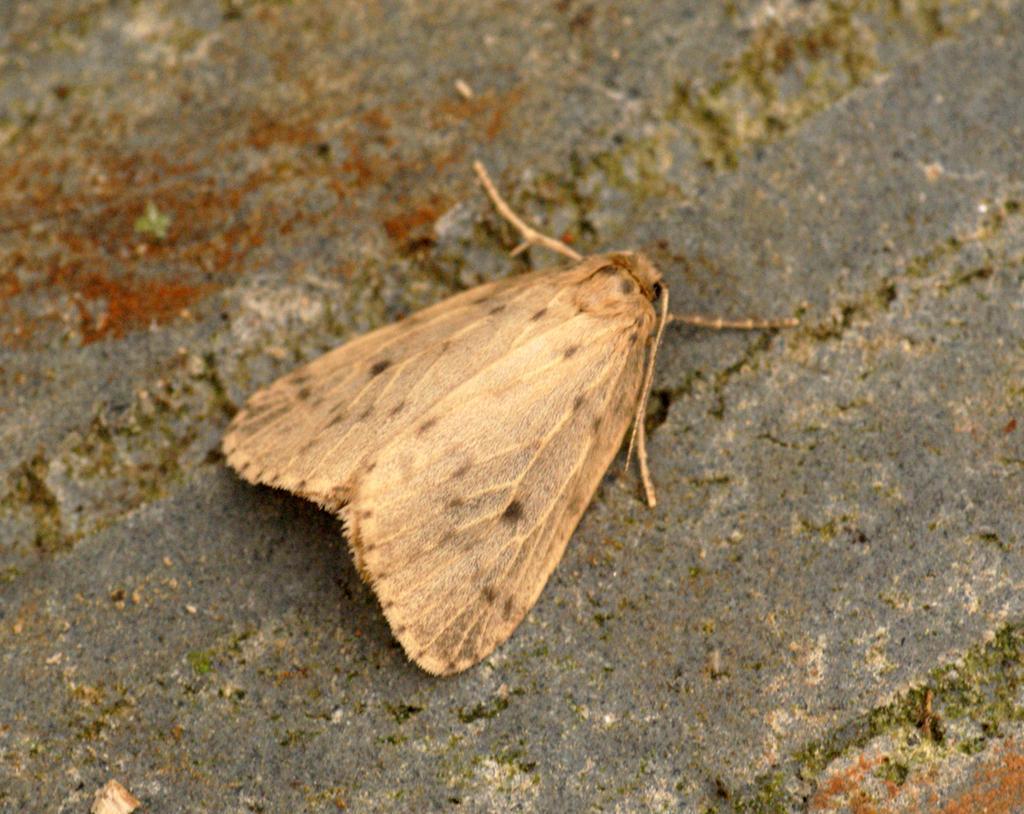Could you give a brief overview of what you see in this image? In this image we can see an insect on the wall. 